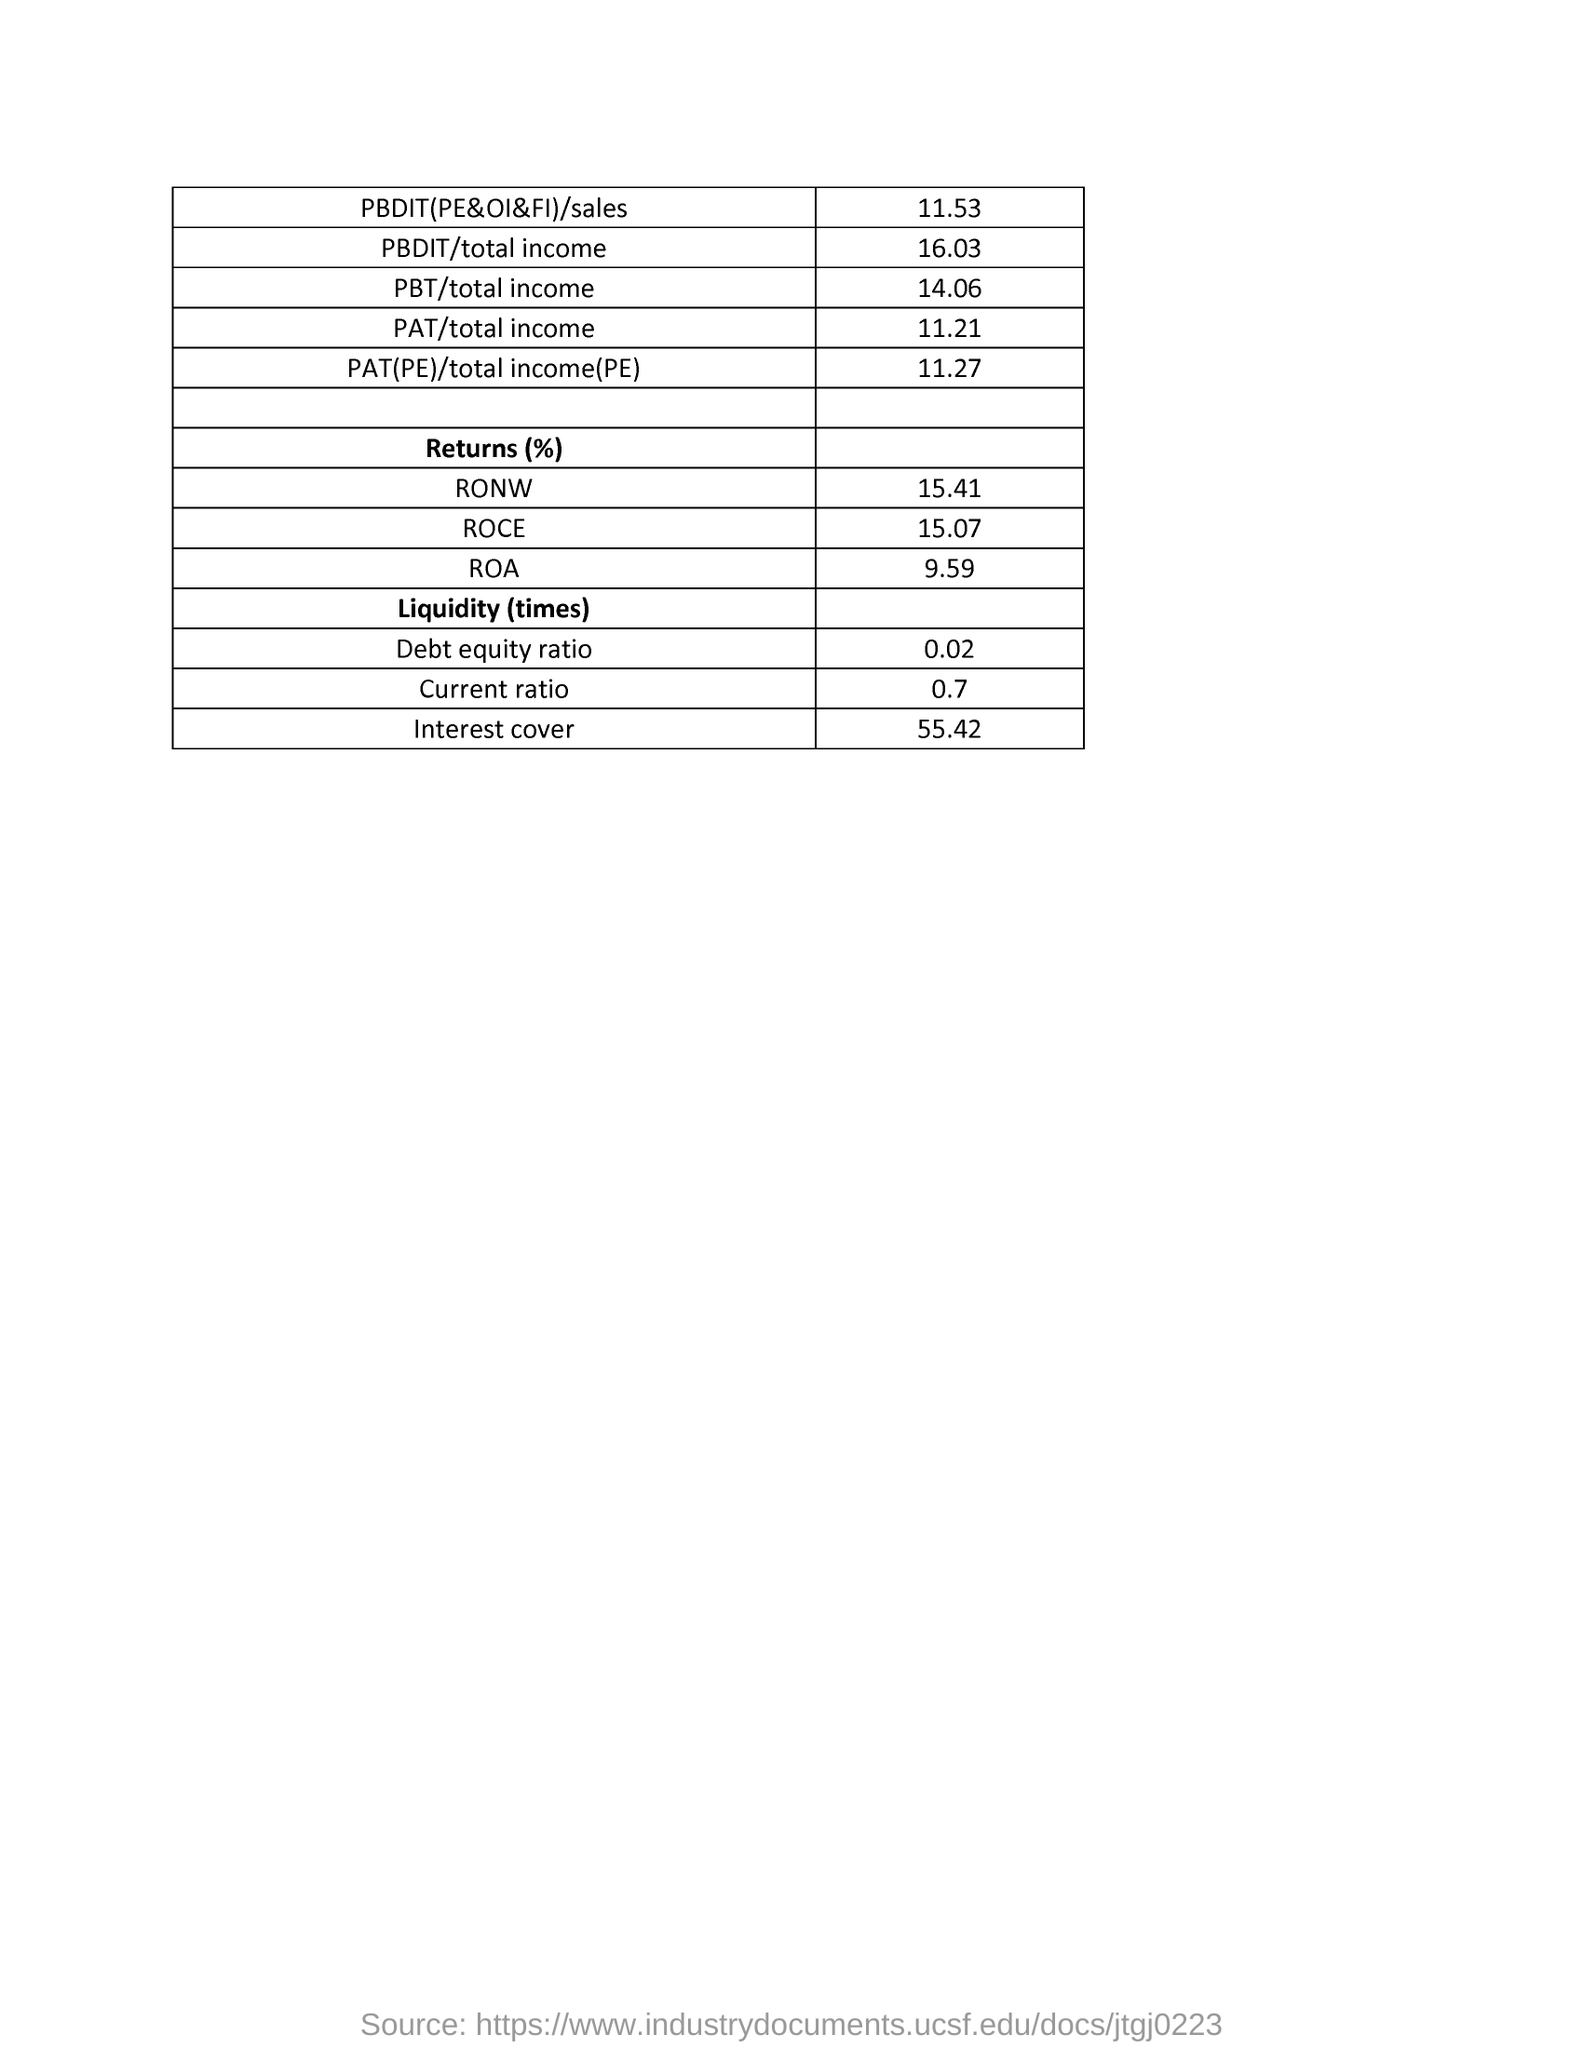How much is the PBDIT sales?
Ensure brevity in your answer.  11.53. How much is the PAT(PE) total income?
Provide a succinct answer. 11.27. How much is the return% of RONW?
Provide a short and direct response. 15.41%. How much is the Return % of ROA?
Provide a short and direct response. 9.59. How much is the debt equity ratio?
Give a very brief answer. 0.02. How much is the interest cover?
Your answer should be very brief. 55.42. 